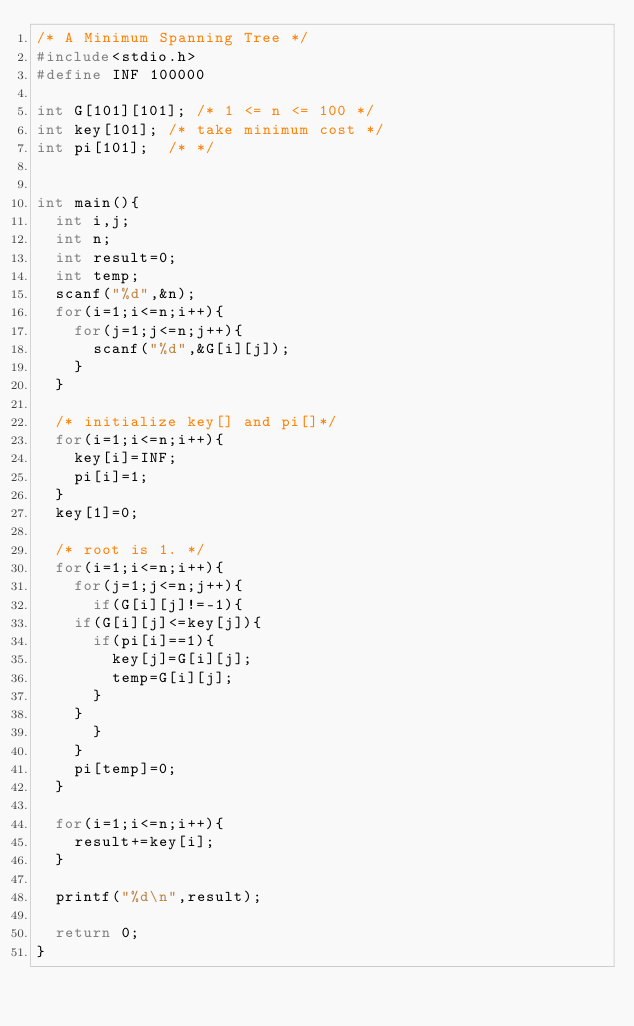Convert code to text. <code><loc_0><loc_0><loc_500><loc_500><_C_>/* A Minimum Spanning Tree */
#include<stdio.h>
#define INF 100000

int G[101][101]; /* 1 <= n <= 100 */
int key[101]; /* take minimum cost */
int pi[101];  /* */


int main(){
  int i,j;
  int n;
  int result=0;
  int temp;
  scanf("%d",&n);
  for(i=1;i<=n;i++){
    for(j=1;j<=n;j++){
      scanf("%d",&G[i][j]);
    }
  }

  /* initialize key[] and pi[]*/
  for(i=1;i<=n;i++){
    key[i]=INF;
    pi[i]=1;
  }
  key[1]=0;

  /* root is 1. */
  for(i=1;i<=n;i++){
    for(j=1;j<=n;j++){
      if(G[i][j]!=-1){
	if(G[i][j]<=key[j]){
	  if(pi[i]==1){
	    key[j]=G[i][j]; 
	    temp=G[i][j];
	  } 
	}
      }
    }
    pi[temp]=0;
  }

  for(i=1;i<=n;i++){
    result+=key[i];
  }

  printf("%d\n",result);

  return 0;
}</code> 